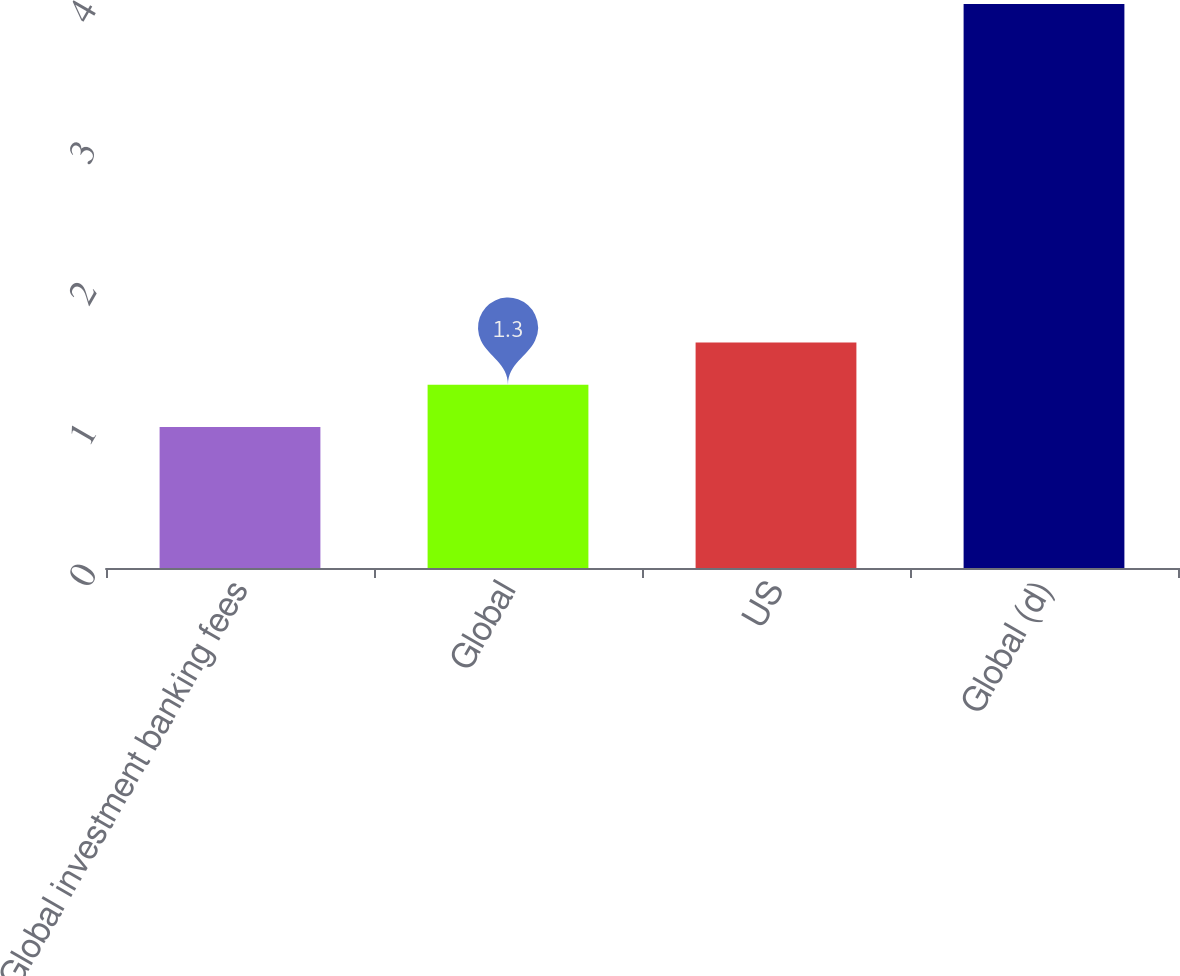<chart> <loc_0><loc_0><loc_500><loc_500><bar_chart><fcel>Global investment banking fees<fcel>Global<fcel>US<fcel>Global (d)<nl><fcel>1<fcel>1.3<fcel>1.6<fcel>4<nl></chart> 